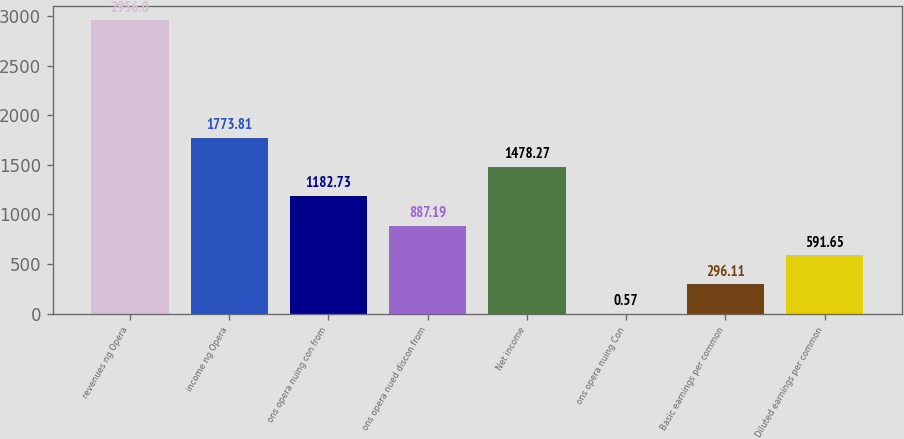Convert chart. <chart><loc_0><loc_0><loc_500><loc_500><bar_chart><fcel>revenues ng Opera<fcel>income ng Opera<fcel>ons opera nuing con from<fcel>ons opera nued discon from<fcel>Net income<fcel>ons opera nuing Con<fcel>Basic earnings per common<fcel>Diluted earnings per common<nl><fcel>2956<fcel>1773.81<fcel>1182.73<fcel>887.19<fcel>1478.27<fcel>0.57<fcel>296.11<fcel>591.65<nl></chart> 